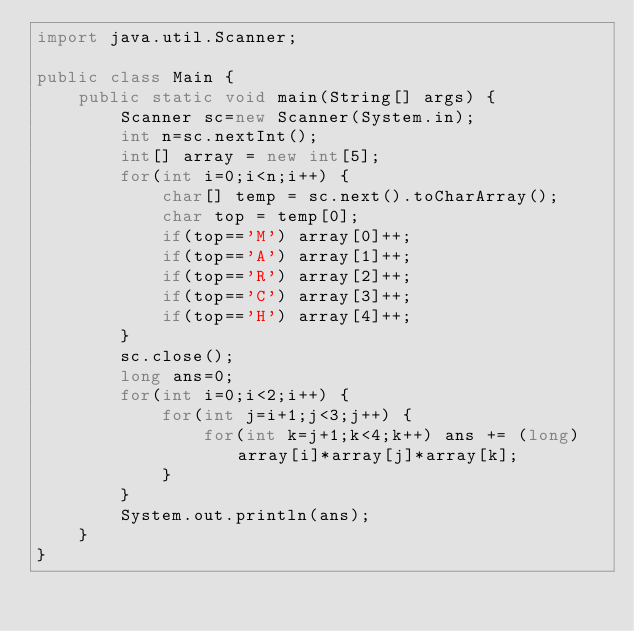Convert code to text. <code><loc_0><loc_0><loc_500><loc_500><_Java_>import java.util.Scanner;

public class Main {
	public static void main(String[] args) {
		Scanner sc=new Scanner(System.in);
		int n=sc.nextInt();
		int[] array = new int[5];
		for(int i=0;i<n;i++) {
			char[] temp = sc.next().toCharArray();
			char top = temp[0];
			if(top=='M') array[0]++;
			if(top=='A') array[1]++;
			if(top=='R') array[2]++;
			if(top=='C') array[3]++;
			if(top=='H') array[4]++;
		}
		sc.close();
		long ans=0;
		for(int i=0;i<2;i++) {
			for(int j=i+1;j<3;j++) {
				for(int k=j+1;k<4;k++) ans += (long)array[i]*array[j]*array[k];
			}
		}
		System.out.println(ans);
	}
}</code> 